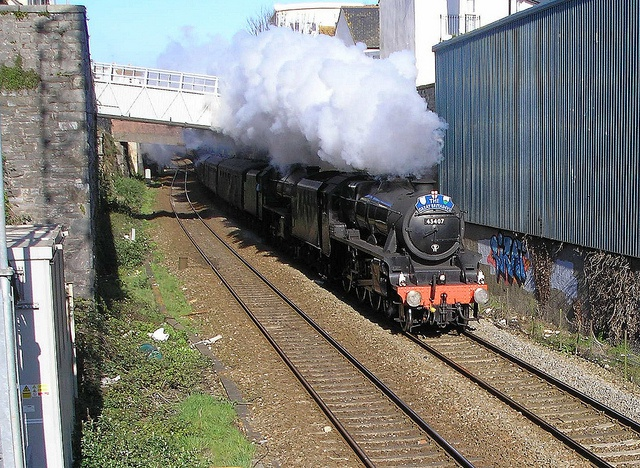Describe the objects in this image and their specific colors. I can see a train in black, gray, and darkgray tones in this image. 